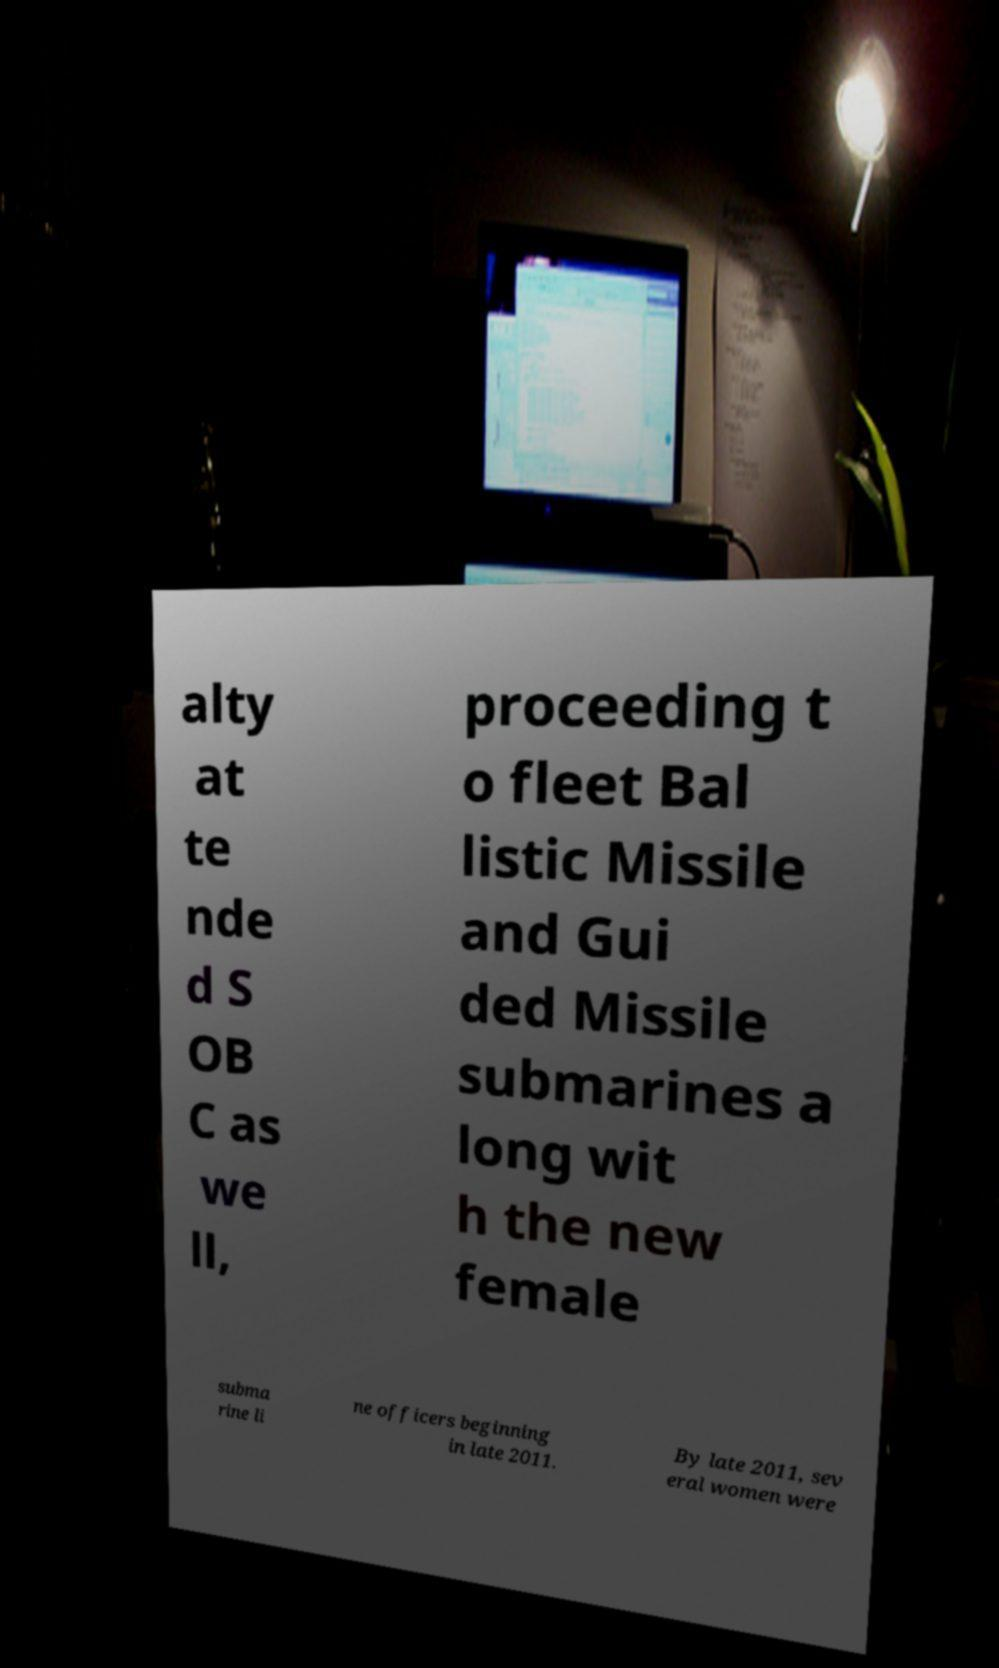Can you accurately transcribe the text from the provided image for me? alty at te nde d S OB C as we ll, proceeding t o fleet Bal listic Missile and Gui ded Missile submarines a long wit h the new female subma rine li ne officers beginning in late 2011. By late 2011, sev eral women were 